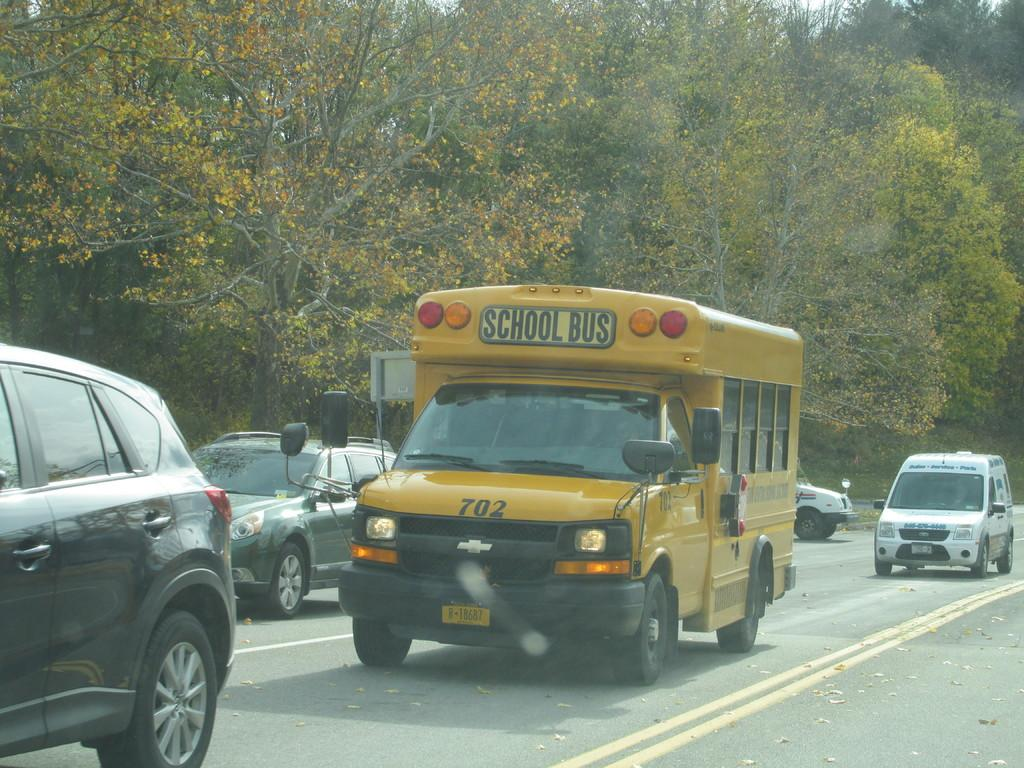How many vehicles are present in the image? There are 4 cars and a van in the image, making a total of 5 vehicles. What type of vehicle is the fifth one in the image? The fifth vehicle is a yellow van with "School Bus" written on it. What can be seen in the background of the image? There are many trees in the background of the image. What verse is being recited by the stone in the image? There is no stone or verse present in the image. 